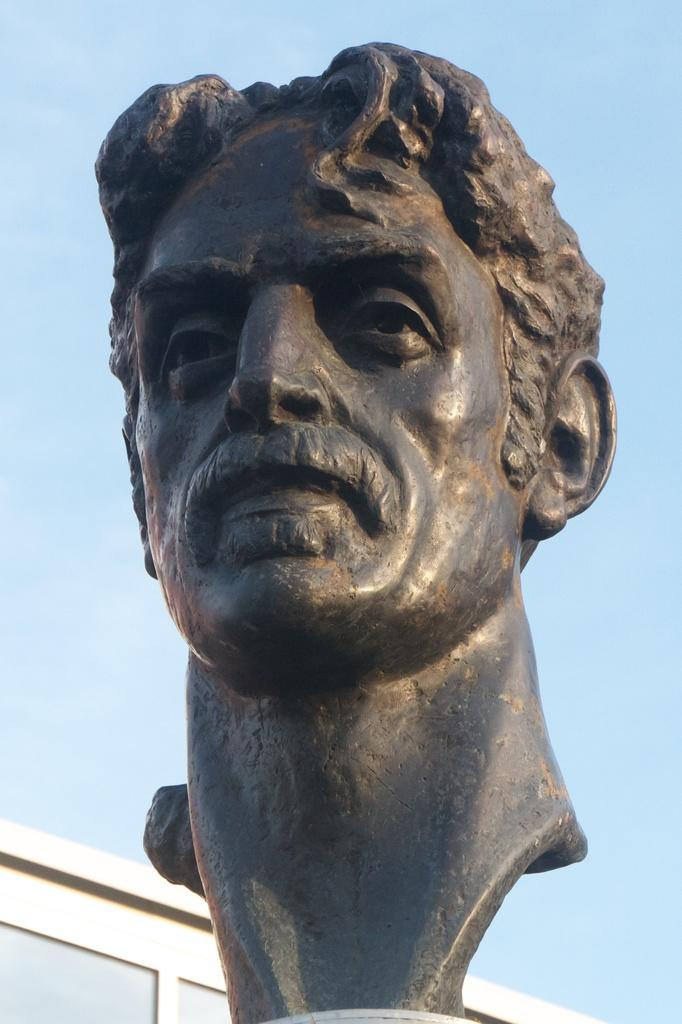What is the main subject in the middle of the image? There is a statue in the middle of the image. What can be seen in the background of the image? There is a building in the background of the image. What is visible in the sky? There are clouds in the sky. What color is the sky in the image? The sky is blue in the image. What type of twig is being used as a cap in the image? There is no twig or cap present in the image. What holiday is being celebrated in the image? There is no indication of a holiday being celebrated in the image. 